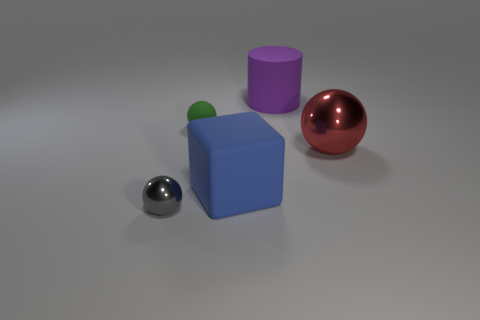What shape is the large object that is in front of the red object right of the small green rubber object?
Provide a short and direct response. Cube. How many other objects are there of the same material as the big purple cylinder?
Give a very brief answer. 2. Is the number of tiny red metal spheres greater than the number of big red balls?
Give a very brief answer. No. What size is the green rubber object on the right side of the metal sphere that is on the left side of the large rubber thing that is behind the large block?
Ensure brevity in your answer.  Small. There is a block; does it have the same size as the metal ball to the left of the red shiny sphere?
Give a very brief answer. No. Is the number of metal balls that are behind the big cube less than the number of big purple cylinders?
Offer a very short reply. No. Are there fewer gray metal objects than rubber objects?
Give a very brief answer. Yes. Is the material of the green sphere the same as the big purple thing?
Make the answer very short. Yes. How many other things are the same size as the gray shiny thing?
Make the answer very short. 1. What is the color of the small sphere behind the metallic sphere that is on the left side of the small green matte object?
Your answer should be very brief. Green. 